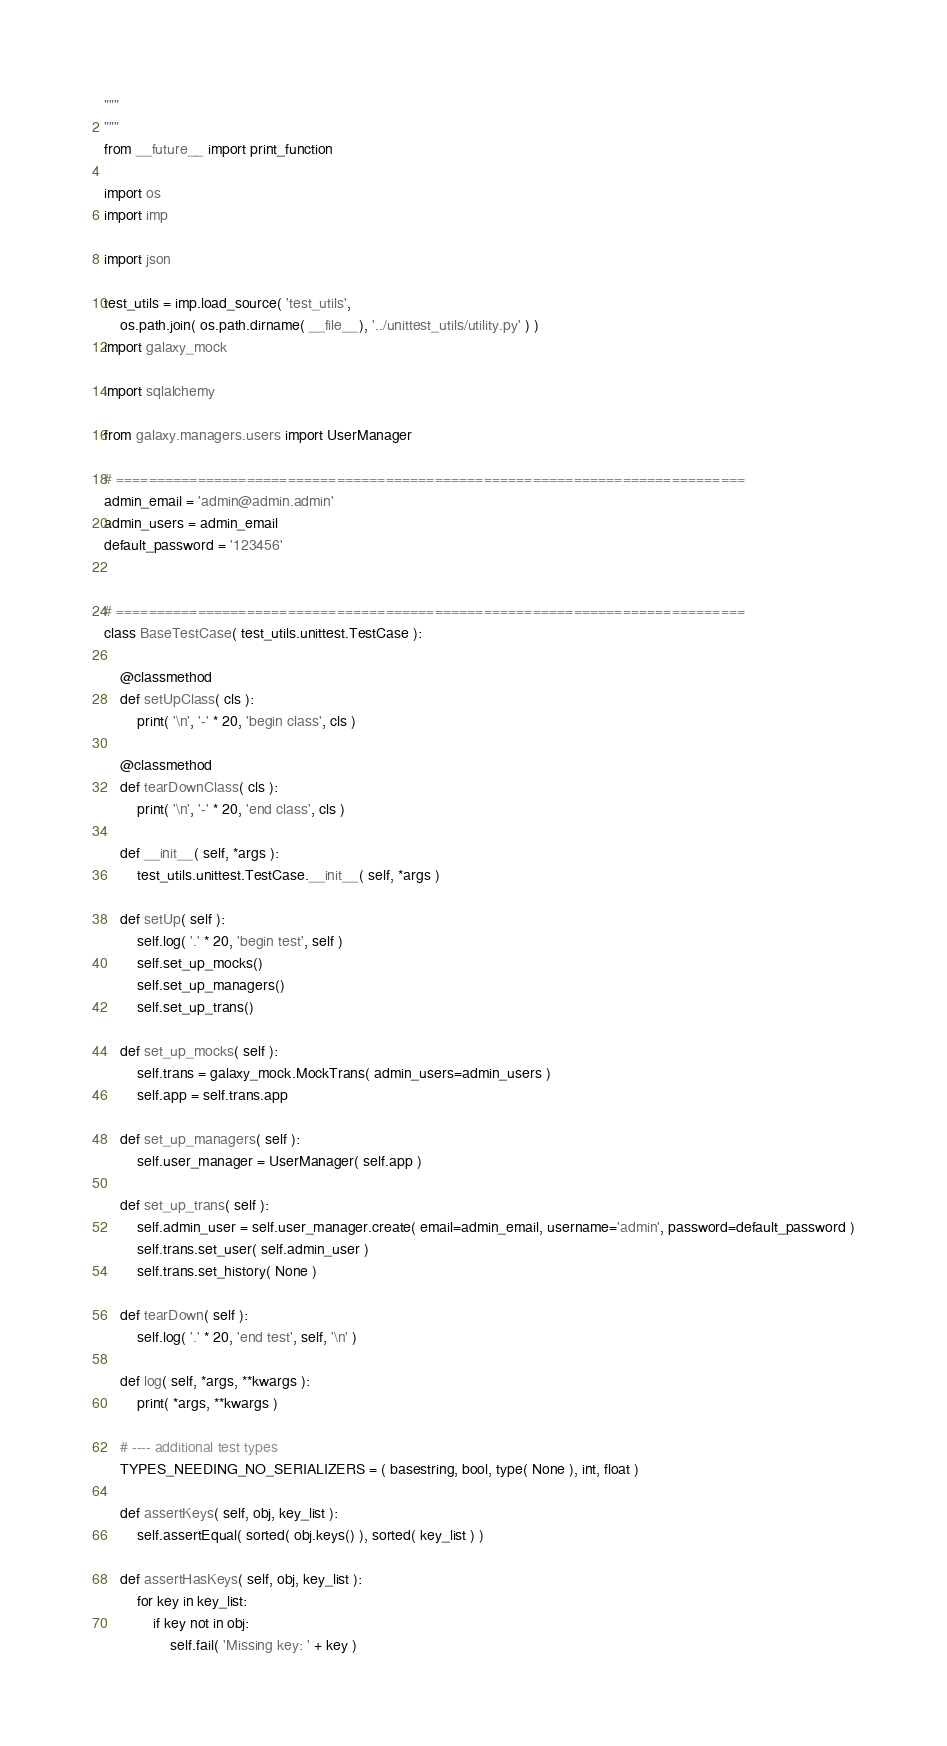Convert code to text. <code><loc_0><loc_0><loc_500><loc_500><_Python_>"""
"""
from __future__ import print_function

import os
import imp

import json

test_utils = imp.load_source( 'test_utils',
    os.path.join( os.path.dirname( __file__), '../unittest_utils/utility.py' ) )
import galaxy_mock

import sqlalchemy

from galaxy.managers.users import UserManager

# =============================================================================
admin_email = 'admin@admin.admin'
admin_users = admin_email
default_password = '123456'


# =============================================================================
class BaseTestCase( test_utils.unittest.TestCase ):

    @classmethod
    def setUpClass( cls ):
        print( '\n', '-' * 20, 'begin class', cls )

    @classmethod
    def tearDownClass( cls ):
        print( '\n', '-' * 20, 'end class', cls )

    def __init__( self, *args ):
        test_utils.unittest.TestCase.__init__( self, *args )

    def setUp( self ):
        self.log( '.' * 20, 'begin test', self )
        self.set_up_mocks()
        self.set_up_managers()
        self.set_up_trans()

    def set_up_mocks( self ):
        self.trans = galaxy_mock.MockTrans( admin_users=admin_users )
        self.app = self.trans.app

    def set_up_managers( self ):
        self.user_manager = UserManager( self.app )

    def set_up_trans( self ):
        self.admin_user = self.user_manager.create( email=admin_email, username='admin', password=default_password )
        self.trans.set_user( self.admin_user )
        self.trans.set_history( None )

    def tearDown( self ):
        self.log( '.' * 20, 'end test', self, '\n' )

    def log( self, *args, **kwargs ):
        print( *args, **kwargs )

    # ---- additional test types
    TYPES_NEEDING_NO_SERIALIZERS = ( basestring, bool, type( None ), int, float )

    def assertKeys( self, obj, key_list ):
        self.assertEqual( sorted( obj.keys() ), sorted( key_list ) )

    def assertHasKeys( self, obj, key_list ):
        for key in key_list:
            if key not in obj:
                self.fail( 'Missing key: ' + key )</code> 